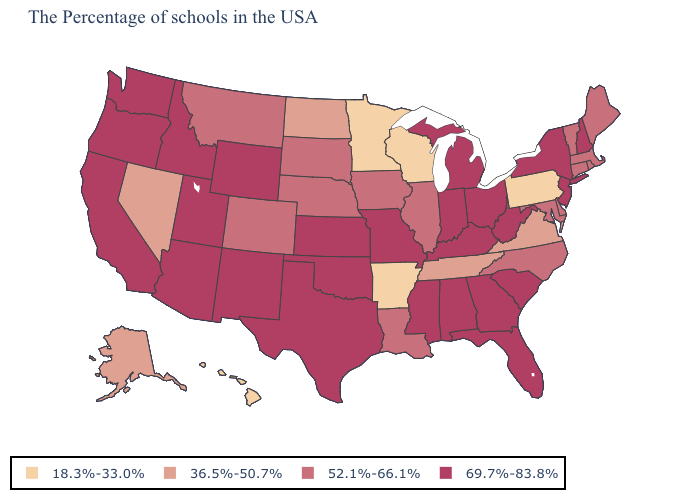Is the legend a continuous bar?
Quick response, please. No. Name the states that have a value in the range 36.5%-50.7%?
Concise answer only. Virginia, Tennessee, North Dakota, Nevada, Alaska. Does New Mexico have the highest value in the West?
Quick response, please. Yes. Name the states that have a value in the range 18.3%-33.0%?
Be succinct. Pennsylvania, Wisconsin, Arkansas, Minnesota, Hawaii. What is the highest value in the South ?
Be succinct. 69.7%-83.8%. Name the states that have a value in the range 36.5%-50.7%?
Answer briefly. Virginia, Tennessee, North Dakota, Nevada, Alaska. How many symbols are there in the legend?
Write a very short answer. 4. Among the states that border Tennessee , does Kentucky have the lowest value?
Keep it brief. No. Does Wisconsin have a lower value than Hawaii?
Concise answer only. No. Is the legend a continuous bar?
Quick response, please. No. Name the states that have a value in the range 36.5%-50.7%?
Write a very short answer. Virginia, Tennessee, North Dakota, Nevada, Alaska. Name the states that have a value in the range 18.3%-33.0%?
Keep it brief. Pennsylvania, Wisconsin, Arkansas, Minnesota, Hawaii. What is the value of Montana?
Answer briefly. 52.1%-66.1%. What is the lowest value in the West?
Give a very brief answer. 18.3%-33.0%. 